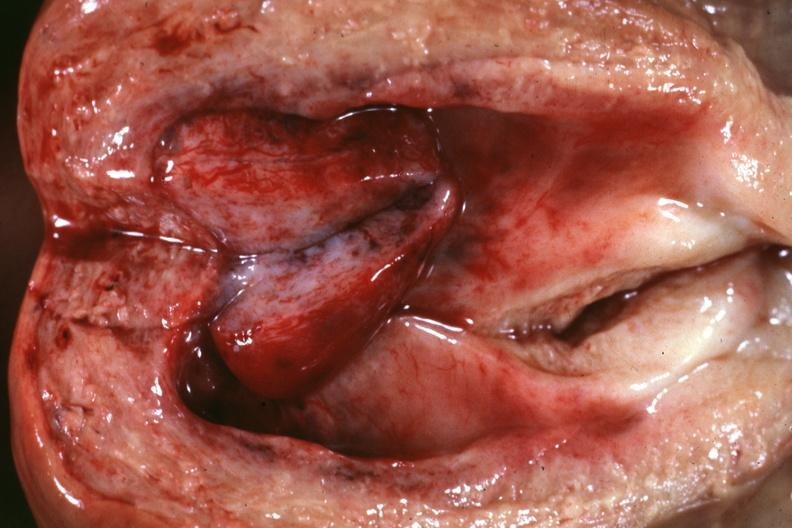what does this image show?
Answer the question using a single word or phrase. Opened uterus close-up with rather large polyp 66yo diabetic female no tissue diagnosis 